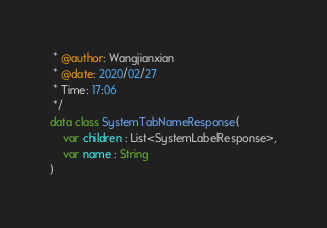Convert code to text. <code><loc_0><loc_0><loc_500><loc_500><_Kotlin_> * @author: Wangjianxian
 * @date: 2020/02/27
 * Time: 17:06
 */
data class SystemTabNameResponse(
    var children : List<SystemLabelResponse>,
    var name : String
)</code> 